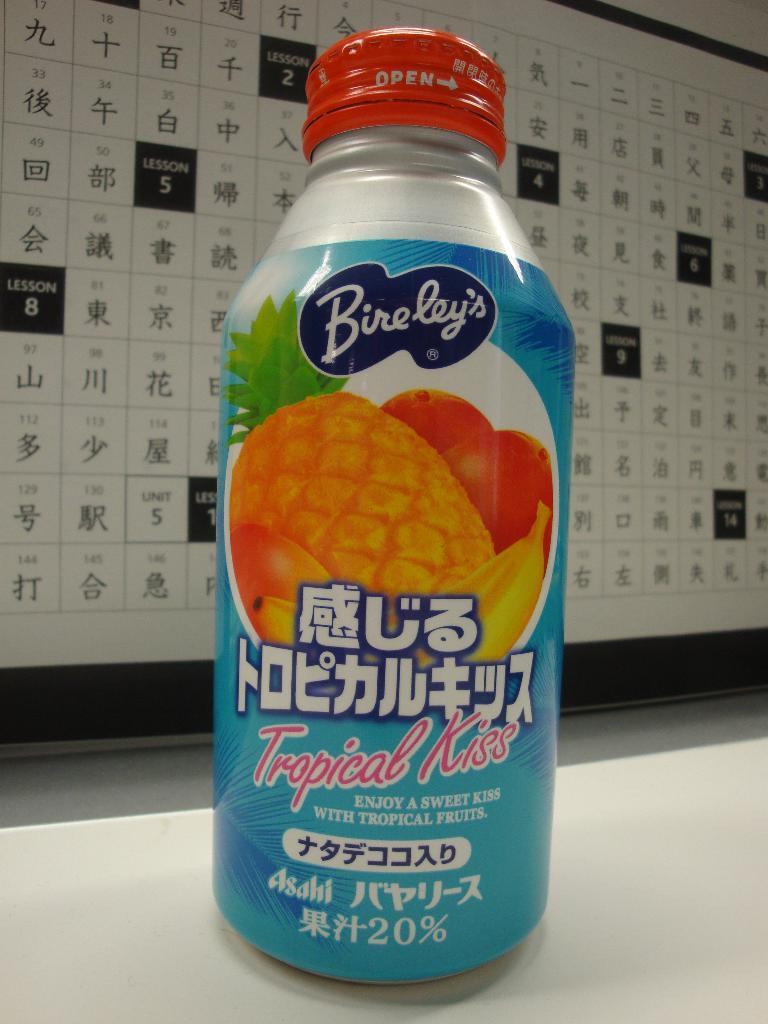<image>
Relay a brief, clear account of the picture shown. An unopened bottle of Bireley's Tropical Kiss juice. 